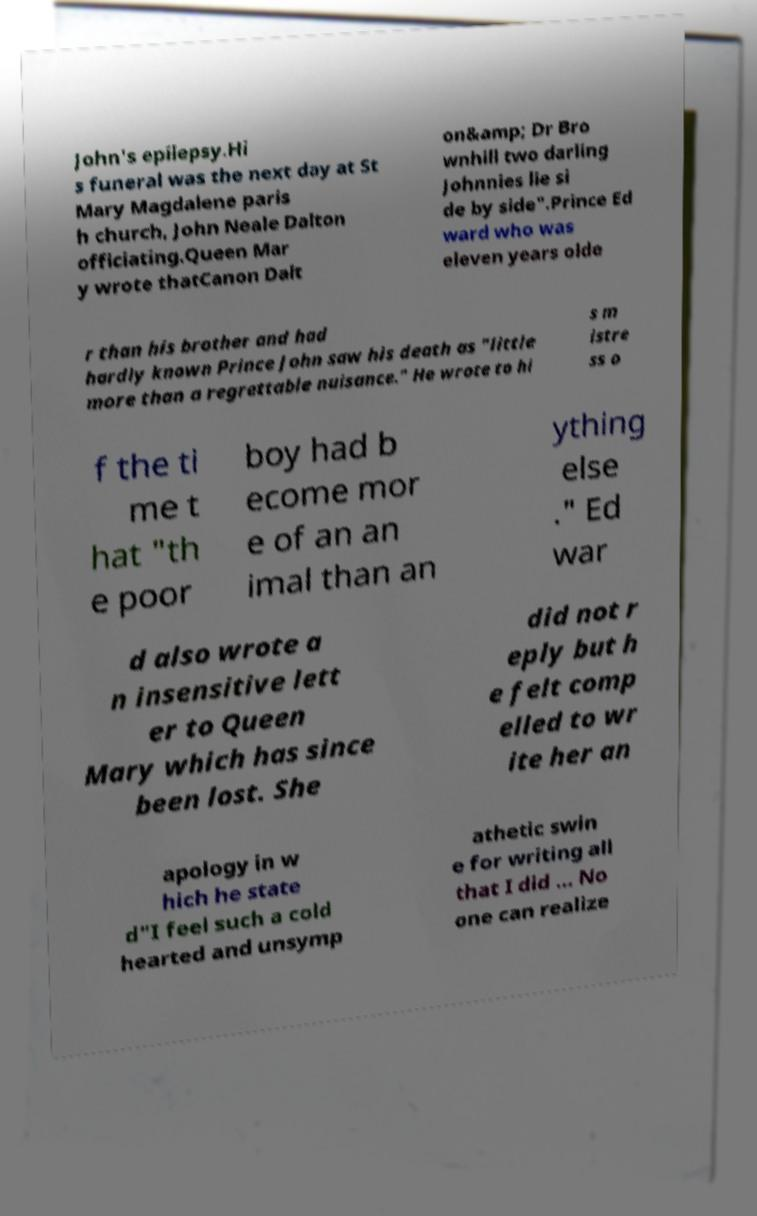Can you read and provide the text displayed in the image?This photo seems to have some interesting text. Can you extract and type it out for me? John's epilepsy.Hi s funeral was the next day at St Mary Magdalene paris h church, John Neale Dalton officiating.Queen Mar y wrote thatCanon Dalt on&amp; Dr Bro wnhill two darling Johnnies lie si de by side".Prince Ed ward who was eleven years olde r than his brother and had hardly known Prince John saw his death as "little more than a regrettable nuisance." He wrote to hi s m istre ss o f the ti me t hat "th e poor boy had b ecome mor e of an an imal than an ything else ." Ed war d also wrote a n insensitive lett er to Queen Mary which has since been lost. She did not r eply but h e felt comp elled to wr ite her an apology in w hich he state d"I feel such a cold hearted and unsymp athetic swin e for writing all that I did ... No one can realize 